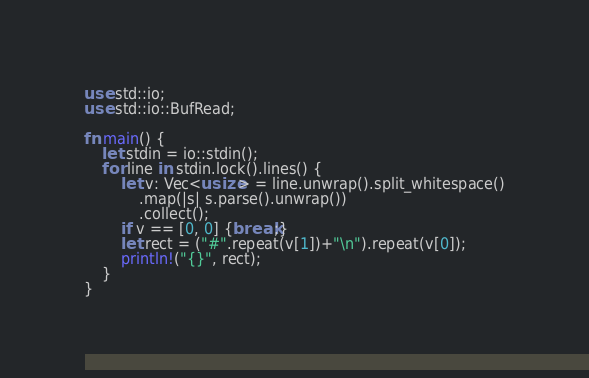Convert code to text. <code><loc_0><loc_0><loc_500><loc_500><_Rust_>use std::io;
use std::io::BufRead;

fn main() {
    let stdin = io::stdin();
    for line in stdin.lock().lines() {
        let v: Vec<usize> = line.unwrap().split_whitespace()
            .map(|s| s.parse().unwrap())
            .collect();
        if v == [0, 0] {break;}
        let rect = ("#".repeat(v[1])+"\n").repeat(v[0]);
        println!("{}", rect);
    }
}
</code> 